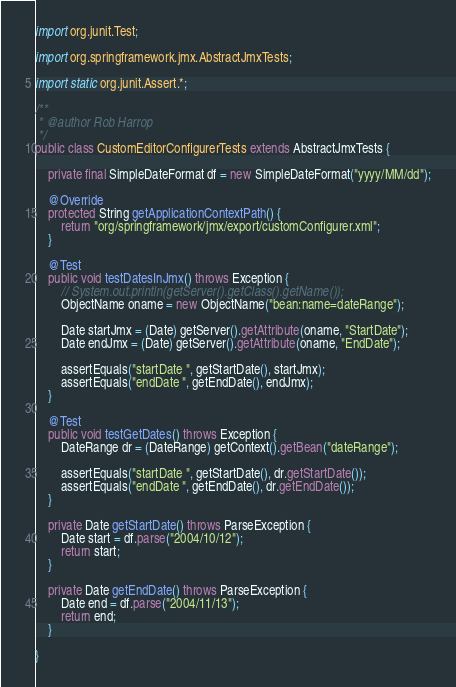Convert code to text. <code><loc_0><loc_0><loc_500><loc_500><_Java_>import org.junit.Test;

import org.springframework.jmx.AbstractJmxTests;

import static org.junit.Assert.*;

/**
 * @author Rob Harrop
 */
public class CustomEditorConfigurerTests extends AbstractJmxTests {

	private final SimpleDateFormat df = new SimpleDateFormat("yyyy/MM/dd");

	@Override
	protected String getApplicationContextPath() {
		return "org/springframework/jmx/export/customConfigurer.xml";
	}

	@Test
	public void testDatesInJmx() throws Exception {
		// System.out.println(getServer().getClass().getName());
		ObjectName oname = new ObjectName("bean:name=dateRange");

		Date startJmx = (Date) getServer().getAttribute(oname, "StartDate");
		Date endJmx = (Date) getServer().getAttribute(oname, "EndDate");

		assertEquals("startDate ", getStartDate(), startJmx);
		assertEquals("endDate ", getEndDate(), endJmx);
	}

	@Test
	public void testGetDates() throws Exception {
		DateRange dr = (DateRange) getContext().getBean("dateRange");

		assertEquals("startDate ", getStartDate(), dr.getStartDate());
		assertEquals("endDate ", getEndDate(), dr.getEndDate());
	}

	private Date getStartDate() throws ParseException {
		Date start = df.parse("2004/10/12");
		return start;
	}

	private Date getEndDate() throws ParseException {
		Date end = df.parse("2004/11/13");
		return end;
	}

}
</code> 